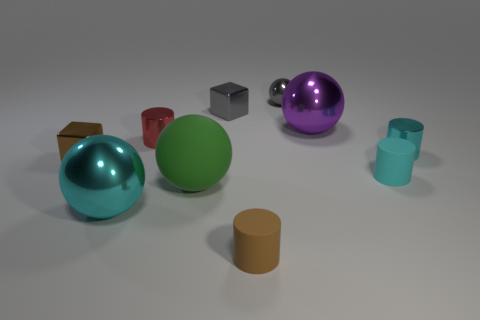Subtract 1 cylinders. How many cylinders are left? 3 Subtract all balls. How many objects are left? 6 Subtract 0 brown balls. How many objects are left? 10 Subtract all big brown metallic cylinders. Subtract all tiny things. How many objects are left? 3 Add 8 cyan shiny things. How many cyan shiny things are left? 10 Add 1 small yellow rubber cubes. How many small yellow rubber cubes exist? 1 